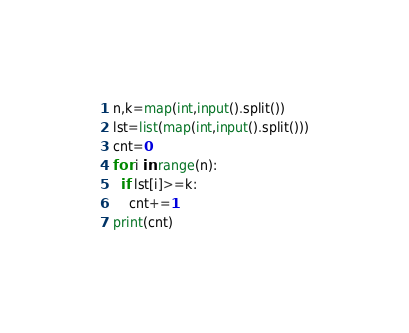<code> <loc_0><loc_0><loc_500><loc_500><_Python_>n,k=map(int,input().split())
lst=list(map(int,input().split()))
cnt=0
for i in range(n):
  if lst[i]>=k:
    cnt+=1
print(cnt)</code> 